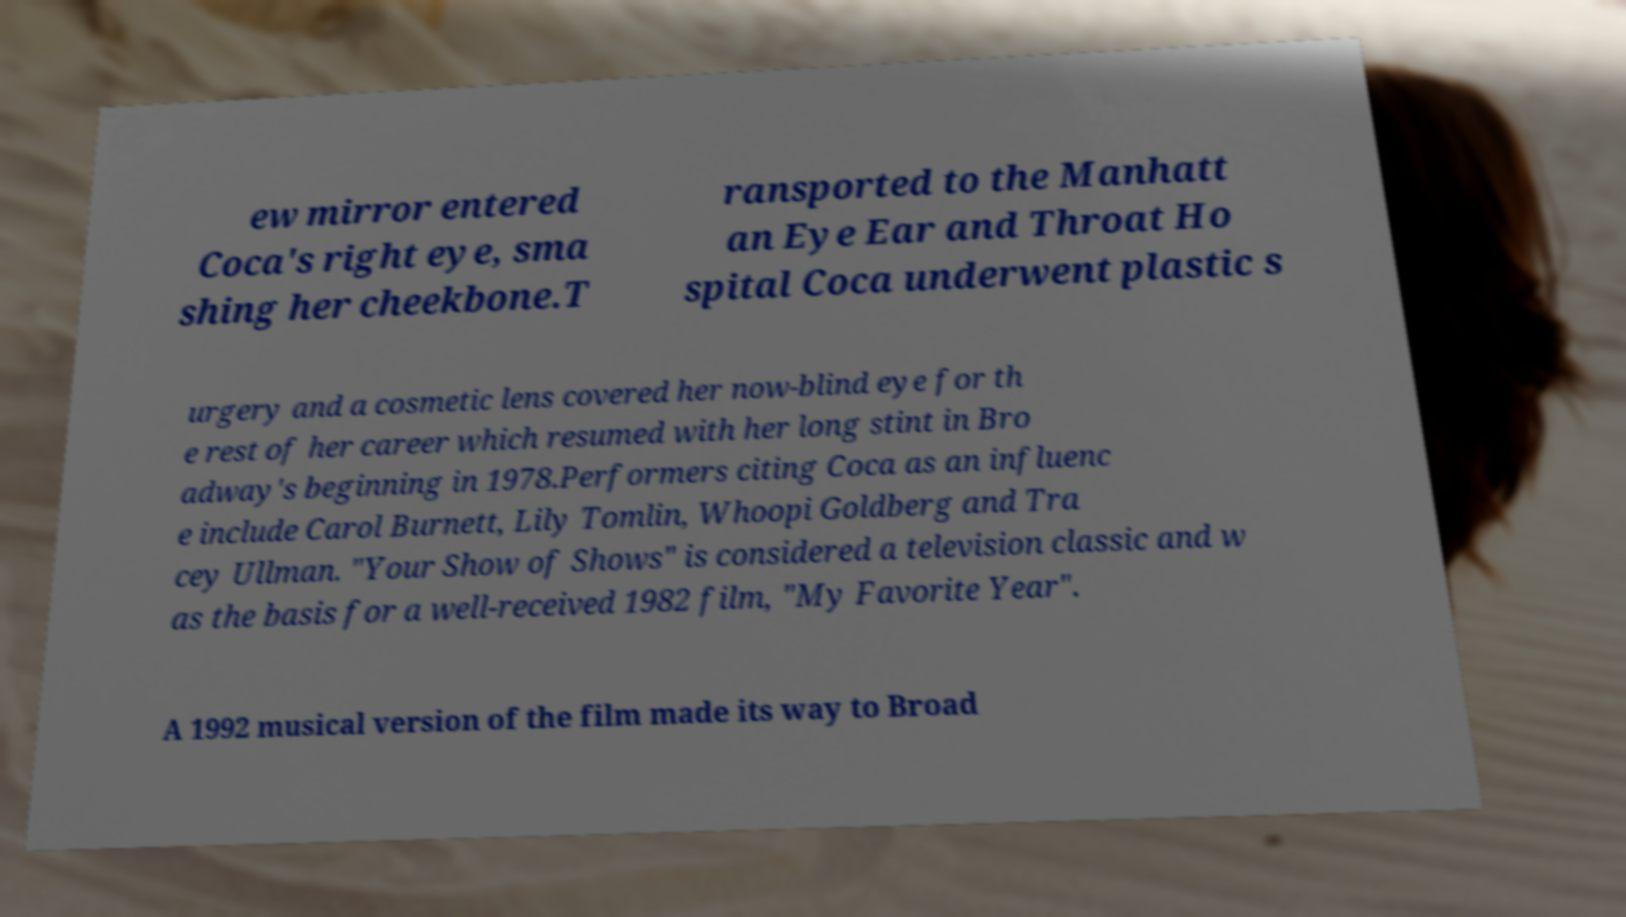For documentation purposes, I need the text within this image transcribed. Could you provide that? ew mirror entered Coca's right eye, sma shing her cheekbone.T ransported to the Manhatt an Eye Ear and Throat Ho spital Coca underwent plastic s urgery and a cosmetic lens covered her now-blind eye for th e rest of her career which resumed with her long stint in Bro adway's beginning in 1978.Performers citing Coca as an influenc e include Carol Burnett, Lily Tomlin, Whoopi Goldberg and Tra cey Ullman. "Your Show of Shows" is considered a television classic and w as the basis for a well-received 1982 film, "My Favorite Year". A 1992 musical version of the film made its way to Broad 